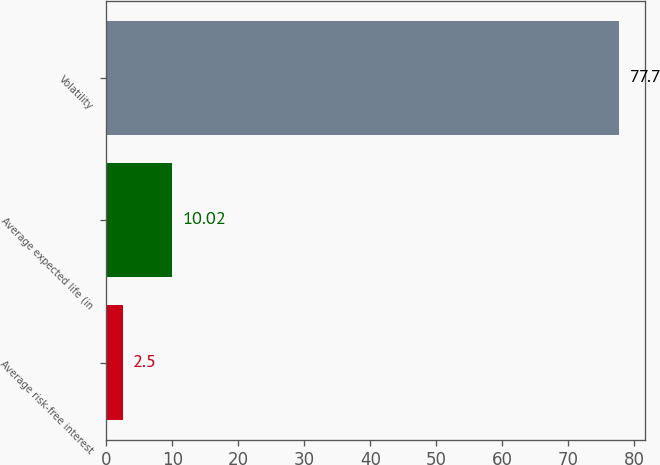<chart> <loc_0><loc_0><loc_500><loc_500><bar_chart><fcel>Average risk-free interest<fcel>Average expected life (in<fcel>Volatility<nl><fcel>2.5<fcel>10.02<fcel>77.7<nl></chart> 